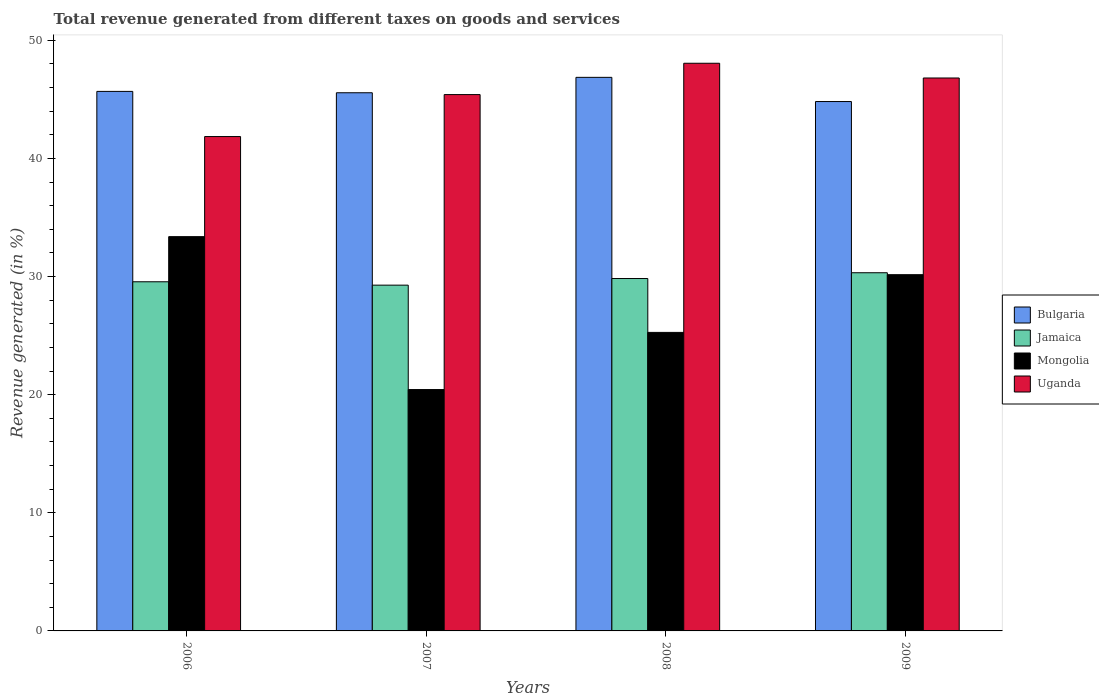How many different coloured bars are there?
Ensure brevity in your answer.  4. How many groups of bars are there?
Ensure brevity in your answer.  4. How many bars are there on the 2nd tick from the left?
Give a very brief answer. 4. What is the total revenue generated in Bulgaria in 2008?
Your response must be concise. 46.86. Across all years, what is the maximum total revenue generated in Mongolia?
Ensure brevity in your answer.  33.38. Across all years, what is the minimum total revenue generated in Bulgaria?
Ensure brevity in your answer.  44.81. In which year was the total revenue generated in Bulgaria maximum?
Your answer should be very brief. 2008. In which year was the total revenue generated in Mongolia minimum?
Your response must be concise. 2007. What is the total total revenue generated in Jamaica in the graph?
Keep it short and to the point. 118.98. What is the difference between the total revenue generated in Jamaica in 2007 and that in 2008?
Make the answer very short. -0.56. What is the difference between the total revenue generated in Bulgaria in 2009 and the total revenue generated in Mongolia in 2006?
Keep it short and to the point. 11.44. What is the average total revenue generated in Uganda per year?
Provide a short and direct response. 45.53. In the year 2009, what is the difference between the total revenue generated in Uganda and total revenue generated in Jamaica?
Keep it short and to the point. 16.49. In how many years, is the total revenue generated in Uganda greater than 18 %?
Ensure brevity in your answer.  4. What is the ratio of the total revenue generated in Uganda in 2008 to that in 2009?
Give a very brief answer. 1.03. Is the difference between the total revenue generated in Uganda in 2007 and 2009 greater than the difference between the total revenue generated in Jamaica in 2007 and 2009?
Offer a very short reply. No. What is the difference between the highest and the second highest total revenue generated in Bulgaria?
Make the answer very short. 1.19. What is the difference between the highest and the lowest total revenue generated in Bulgaria?
Your answer should be compact. 2.05. In how many years, is the total revenue generated in Bulgaria greater than the average total revenue generated in Bulgaria taken over all years?
Keep it short and to the point. 1. Is the sum of the total revenue generated in Mongolia in 2006 and 2007 greater than the maximum total revenue generated in Bulgaria across all years?
Give a very brief answer. Yes. What does the 3rd bar from the right in 2008 represents?
Provide a short and direct response. Jamaica. How many bars are there?
Keep it short and to the point. 16. How many years are there in the graph?
Your response must be concise. 4. What is the difference between two consecutive major ticks on the Y-axis?
Your answer should be very brief. 10. Are the values on the major ticks of Y-axis written in scientific E-notation?
Ensure brevity in your answer.  No. Does the graph contain any zero values?
Provide a succinct answer. No. What is the title of the graph?
Give a very brief answer. Total revenue generated from different taxes on goods and services. What is the label or title of the Y-axis?
Offer a terse response. Revenue generated (in %). What is the Revenue generated (in %) in Bulgaria in 2006?
Your answer should be very brief. 45.67. What is the Revenue generated (in %) of Jamaica in 2006?
Make the answer very short. 29.56. What is the Revenue generated (in %) in Mongolia in 2006?
Provide a succinct answer. 33.38. What is the Revenue generated (in %) of Uganda in 2006?
Provide a short and direct response. 41.85. What is the Revenue generated (in %) in Bulgaria in 2007?
Keep it short and to the point. 45.56. What is the Revenue generated (in %) in Jamaica in 2007?
Your answer should be very brief. 29.27. What is the Revenue generated (in %) of Mongolia in 2007?
Your response must be concise. 20.43. What is the Revenue generated (in %) of Uganda in 2007?
Provide a short and direct response. 45.4. What is the Revenue generated (in %) of Bulgaria in 2008?
Offer a terse response. 46.86. What is the Revenue generated (in %) of Jamaica in 2008?
Your response must be concise. 29.83. What is the Revenue generated (in %) in Mongolia in 2008?
Ensure brevity in your answer.  25.27. What is the Revenue generated (in %) of Uganda in 2008?
Offer a terse response. 48.06. What is the Revenue generated (in %) of Bulgaria in 2009?
Make the answer very short. 44.81. What is the Revenue generated (in %) in Jamaica in 2009?
Provide a short and direct response. 30.32. What is the Revenue generated (in %) of Mongolia in 2009?
Keep it short and to the point. 30.16. What is the Revenue generated (in %) in Uganda in 2009?
Your response must be concise. 46.81. Across all years, what is the maximum Revenue generated (in %) in Bulgaria?
Make the answer very short. 46.86. Across all years, what is the maximum Revenue generated (in %) in Jamaica?
Keep it short and to the point. 30.32. Across all years, what is the maximum Revenue generated (in %) in Mongolia?
Provide a short and direct response. 33.38. Across all years, what is the maximum Revenue generated (in %) in Uganda?
Your response must be concise. 48.06. Across all years, what is the minimum Revenue generated (in %) of Bulgaria?
Keep it short and to the point. 44.81. Across all years, what is the minimum Revenue generated (in %) in Jamaica?
Your response must be concise. 29.27. Across all years, what is the minimum Revenue generated (in %) of Mongolia?
Your answer should be compact. 20.43. Across all years, what is the minimum Revenue generated (in %) of Uganda?
Offer a terse response. 41.85. What is the total Revenue generated (in %) in Bulgaria in the graph?
Offer a terse response. 182.91. What is the total Revenue generated (in %) in Jamaica in the graph?
Make the answer very short. 118.98. What is the total Revenue generated (in %) in Mongolia in the graph?
Ensure brevity in your answer.  109.24. What is the total Revenue generated (in %) in Uganda in the graph?
Provide a short and direct response. 182.12. What is the difference between the Revenue generated (in %) in Bulgaria in 2006 and that in 2007?
Give a very brief answer. 0.11. What is the difference between the Revenue generated (in %) in Jamaica in 2006 and that in 2007?
Your answer should be compact. 0.28. What is the difference between the Revenue generated (in %) of Mongolia in 2006 and that in 2007?
Provide a succinct answer. 12.94. What is the difference between the Revenue generated (in %) of Uganda in 2006 and that in 2007?
Your response must be concise. -3.55. What is the difference between the Revenue generated (in %) in Bulgaria in 2006 and that in 2008?
Your answer should be compact. -1.19. What is the difference between the Revenue generated (in %) of Jamaica in 2006 and that in 2008?
Give a very brief answer. -0.28. What is the difference between the Revenue generated (in %) in Mongolia in 2006 and that in 2008?
Your answer should be very brief. 8.11. What is the difference between the Revenue generated (in %) in Uganda in 2006 and that in 2008?
Your response must be concise. -6.2. What is the difference between the Revenue generated (in %) of Bulgaria in 2006 and that in 2009?
Make the answer very short. 0.86. What is the difference between the Revenue generated (in %) of Jamaica in 2006 and that in 2009?
Keep it short and to the point. -0.77. What is the difference between the Revenue generated (in %) in Mongolia in 2006 and that in 2009?
Provide a succinct answer. 3.22. What is the difference between the Revenue generated (in %) in Uganda in 2006 and that in 2009?
Offer a terse response. -4.96. What is the difference between the Revenue generated (in %) of Bulgaria in 2007 and that in 2008?
Provide a succinct answer. -1.3. What is the difference between the Revenue generated (in %) in Jamaica in 2007 and that in 2008?
Provide a succinct answer. -0.56. What is the difference between the Revenue generated (in %) of Mongolia in 2007 and that in 2008?
Your answer should be very brief. -4.84. What is the difference between the Revenue generated (in %) in Uganda in 2007 and that in 2008?
Keep it short and to the point. -2.65. What is the difference between the Revenue generated (in %) of Bulgaria in 2007 and that in 2009?
Provide a short and direct response. 0.74. What is the difference between the Revenue generated (in %) of Jamaica in 2007 and that in 2009?
Provide a short and direct response. -1.05. What is the difference between the Revenue generated (in %) of Mongolia in 2007 and that in 2009?
Provide a short and direct response. -9.73. What is the difference between the Revenue generated (in %) of Uganda in 2007 and that in 2009?
Provide a short and direct response. -1.4. What is the difference between the Revenue generated (in %) of Bulgaria in 2008 and that in 2009?
Make the answer very short. 2.05. What is the difference between the Revenue generated (in %) in Jamaica in 2008 and that in 2009?
Provide a short and direct response. -0.49. What is the difference between the Revenue generated (in %) of Mongolia in 2008 and that in 2009?
Ensure brevity in your answer.  -4.89. What is the difference between the Revenue generated (in %) of Uganda in 2008 and that in 2009?
Provide a succinct answer. 1.25. What is the difference between the Revenue generated (in %) of Bulgaria in 2006 and the Revenue generated (in %) of Jamaica in 2007?
Offer a terse response. 16.4. What is the difference between the Revenue generated (in %) of Bulgaria in 2006 and the Revenue generated (in %) of Mongolia in 2007?
Give a very brief answer. 25.24. What is the difference between the Revenue generated (in %) in Bulgaria in 2006 and the Revenue generated (in %) in Uganda in 2007?
Your answer should be compact. 0.27. What is the difference between the Revenue generated (in %) in Jamaica in 2006 and the Revenue generated (in %) in Mongolia in 2007?
Your answer should be very brief. 9.12. What is the difference between the Revenue generated (in %) of Jamaica in 2006 and the Revenue generated (in %) of Uganda in 2007?
Your answer should be very brief. -15.85. What is the difference between the Revenue generated (in %) of Mongolia in 2006 and the Revenue generated (in %) of Uganda in 2007?
Ensure brevity in your answer.  -12.03. What is the difference between the Revenue generated (in %) in Bulgaria in 2006 and the Revenue generated (in %) in Jamaica in 2008?
Offer a very short reply. 15.84. What is the difference between the Revenue generated (in %) in Bulgaria in 2006 and the Revenue generated (in %) in Mongolia in 2008?
Give a very brief answer. 20.4. What is the difference between the Revenue generated (in %) in Bulgaria in 2006 and the Revenue generated (in %) in Uganda in 2008?
Give a very brief answer. -2.38. What is the difference between the Revenue generated (in %) in Jamaica in 2006 and the Revenue generated (in %) in Mongolia in 2008?
Offer a very short reply. 4.29. What is the difference between the Revenue generated (in %) of Jamaica in 2006 and the Revenue generated (in %) of Uganda in 2008?
Provide a succinct answer. -18.5. What is the difference between the Revenue generated (in %) of Mongolia in 2006 and the Revenue generated (in %) of Uganda in 2008?
Ensure brevity in your answer.  -14.68. What is the difference between the Revenue generated (in %) of Bulgaria in 2006 and the Revenue generated (in %) of Jamaica in 2009?
Your answer should be very brief. 15.35. What is the difference between the Revenue generated (in %) of Bulgaria in 2006 and the Revenue generated (in %) of Mongolia in 2009?
Ensure brevity in your answer.  15.52. What is the difference between the Revenue generated (in %) in Bulgaria in 2006 and the Revenue generated (in %) in Uganda in 2009?
Your answer should be very brief. -1.14. What is the difference between the Revenue generated (in %) in Jamaica in 2006 and the Revenue generated (in %) in Mongolia in 2009?
Keep it short and to the point. -0.6. What is the difference between the Revenue generated (in %) in Jamaica in 2006 and the Revenue generated (in %) in Uganda in 2009?
Your response must be concise. -17.25. What is the difference between the Revenue generated (in %) of Mongolia in 2006 and the Revenue generated (in %) of Uganda in 2009?
Offer a terse response. -13.43. What is the difference between the Revenue generated (in %) of Bulgaria in 2007 and the Revenue generated (in %) of Jamaica in 2008?
Offer a very short reply. 15.73. What is the difference between the Revenue generated (in %) of Bulgaria in 2007 and the Revenue generated (in %) of Mongolia in 2008?
Provide a short and direct response. 20.29. What is the difference between the Revenue generated (in %) of Bulgaria in 2007 and the Revenue generated (in %) of Uganda in 2008?
Provide a short and direct response. -2.5. What is the difference between the Revenue generated (in %) in Jamaica in 2007 and the Revenue generated (in %) in Mongolia in 2008?
Offer a very short reply. 4. What is the difference between the Revenue generated (in %) in Jamaica in 2007 and the Revenue generated (in %) in Uganda in 2008?
Your answer should be compact. -18.78. What is the difference between the Revenue generated (in %) of Mongolia in 2007 and the Revenue generated (in %) of Uganda in 2008?
Your response must be concise. -27.62. What is the difference between the Revenue generated (in %) of Bulgaria in 2007 and the Revenue generated (in %) of Jamaica in 2009?
Ensure brevity in your answer.  15.24. What is the difference between the Revenue generated (in %) in Bulgaria in 2007 and the Revenue generated (in %) in Mongolia in 2009?
Keep it short and to the point. 15.4. What is the difference between the Revenue generated (in %) of Bulgaria in 2007 and the Revenue generated (in %) of Uganda in 2009?
Your answer should be very brief. -1.25. What is the difference between the Revenue generated (in %) of Jamaica in 2007 and the Revenue generated (in %) of Mongolia in 2009?
Give a very brief answer. -0.89. What is the difference between the Revenue generated (in %) in Jamaica in 2007 and the Revenue generated (in %) in Uganda in 2009?
Keep it short and to the point. -17.54. What is the difference between the Revenue generated (in %) in Mongolia in 2007 and the Revenue generated (in %) in Uganda in 2009?
Your answer should be very brief. -26.38. What is the difference between the Revenue generated (in %) of Bulgaria in 2008 and the Revenue generated (in %) of Jamaica in 2009?
Offer a terse response. 16.54. What is the difference between the Revenue generated (in %) in Bulgaria in 2008 and the Revenue generated (in %) in Mongolia in 2009?
Offer a very short reply. 16.7. What is the difference between the Revenue generated (in %) in Bulgaria in 2008 and the Revenue generated (in %) in Uganda in 2009?
Keep it short and to the point. 0.05. What is the difference between the Revenue generated (in %) of Jamaica in 2008 and the Revenue generated (in %) of Mongolia in 2009?
Your answer should be very brief. -0.32. What is the difference between the Revenue generated (in %) in Jamaica in 2008 and the Revenue generated (in %) in Uganda in 2009?
Your response must be concise. -16.98. What is the difference between the Revenue generated (in %) in Mongolia in 2008 and the Revenue generated (in %) in Uganda in 2009?
Offer a terse response. -21.54. What is the average Revenue generated (in %) in Bulgaria per year?
Give a very brief answer. 45.73. What is the average Revenue generated (in %) of Jamaica per year?
Ensure brevity in your answer.  29.75. What is the average Revenue generated (in %) in Mongolia per year?
Ensure brevity in your answer.  27.31. What is the average Revenue generated (in %) in Uganda per year?
Your response must be concise. 45.53. In the year 2006, what is the difference between the Revenue generated (in %) in Bulgaria and Revenue generated (in %) in Jamaica?
Offer a terse response. 16.12. In the year 2006, what is the difference between the Revenue generated (in %) of Bulgaria and Revenue generated (in %) of Mongolia?
Provide a short and direct response. 12.3. In the year 2006, what is the difference between the Revenue generated (in %) in Bulgaria and Revenue generated (in %) in Uganda?
Your answer should be compact. 3.82. In the year 2006, what is the difference between the Revenue generated (in %) of Jamaica and Revenue generated (in %) of Mongolia?
Keep it short and to the point. -3.82. In the year 2006, what is the difference between the Revenue generated (in %) in Jamaica and Revenue generated (in %) in Uganda?
Your answer should be compact. -12.29. In the year 2006, what is the difference between the Revenue generated (in %) of Mongolia and Revenue generated (in %) of Uganda?
Your answer should be very brief. -8.47. In the year 2007, what is the difference between the Revenue generated (in %) in Bulgaria and Revenue generated (in %) in Jamaica?
Keep it short and to the point. 16.29. In the year 2007, what is the difference between the Revenue generated (in %) in Bulgaria and Revenue generated (in %) in Mongolia?
Make the answer very short. 25.13. In the year 2007, what is the difference between the Revenue generated (in %) in Bulgaria and Revenue generated (in %) in Uganda?
Your answer should be compact. 0.15. In the year 2007, what is the difference between the Revenue generated (in %) in Jamaica and Revenue generated (in %) in Mongolia?
Give a very brief answer. 8.84. In the year 2007, what is the difference between the Revenue generated (in %) of Jamaica and Revenue generated (in %) of Uganda?
Ensure brevity in your answer.  -16.13. In the year 2007, what is the difference between the Revenue generated (in %) of Mongolia and Revenue generated (in %) of Uganda?
Your answer should be very brief. -24.97. In the year 2008, what is the difference between the Revenue generated (in %) of Bulgaria and Revenue generated (in %) of Jamaica?
Provide a succinct answer. 17.03. In the year 2008, what is the difference between the Revenue generated (in %) of Bulgaria and Revenue generated (in %) of Mongolia?
Provide a succinct answer. 21.59. In the year 2008, what is the difference between the Revenue generated (in %) of Bulgaria and Revenue generated (in %) of Uganda?
Keep it short and to the point. -1.19. In the year 2008, what is the difference between the Revenue generated (in %) in Jamaica and Revenue generated (in %) in Mongolia?
Provide a succinct answer. 4.56. In the year 2008, what is the difference between the Revenue generated (in %) of Jamaica and Revenue generated (in %) of Uganda?
Give a very brief answer. -18.22. In the year 2008, what is the difference between the Revenue generated (in %) in Mongolia and Revenue generated (in %) in Uganda?
Ensure brevity in your answer.  -22.78. In the year 2009, what is the difference between the Revenue generated (in %) of Bulgaria and Revenue generated (in %) of Jamaica?
Give a very brief answer. 14.49. In the year 2009, what is the difference between the Revenue generated (in %) of Bulgaria and Revenue generated (in %) of Mongolia?
Provide a short and direct response. 14.66. In the year 2009, what is the difference between the Revenue generated (in %) in Bulgaria and Revenue generated (in %) in Uganda?
Offer a terse response. -1.99. In the year 2009, what is the difference between the Revenue generated (in %) of Jamaica and Revenue generated (in %) of Mongolia?
Your answer should be very brief. 0.16. In the year 2009, what is the difference between the Revenue generated (in %) of Jamaica and Revenue generated (in %) of Uganda?
Keep it short and to the point. -16.49. In the year 2009, what is the difference between the Revenue generated (in %) of Mongolia and Revenue generated (in %) of Uganda?
Ensure brevity in your answer.  -16.65. What is the ratio of the Revenue generated (in %) in Bulgaria in 2006 to that in 2007?
Keep it short and to the point. 1. What is the ratio of the Revenue generated (in %) in Jamaica in 2006 to that in 2007?
Make the answer very short. 1.01. What is the ratio of the Revenue generated (in %) in Mongolia in 2006 to that in 2007?
Offer a terse response. 1.63. What is the ratio of the Revenue generated (in %) of Uganda in 2006 to that in 2007?
Make the answer very short. 0.92. What is the ratio of the Revenue generated (in %) in Bulgaria in 2006 to that in 2008?
Your response must be concise. 0.97. What is the ratio of the Revenue generated (in %) in Jamaica in 2006 to that in 2008?
Make the answer very short. 0.99. What is the ratio of the Revenue generated (in %) in Mongolia in 2006 to that in 2008?
Make the answer very short. 1.32. What is the ratio of the Revenue generated (in %) in Uganda in 2006 to that in 2008?
Your answer should be very brief. 0.87. What is the ratio of the Revenue generated (in %) of Bulgaria in 2006 to that in 2009?
Offer a very short reply. 1.02. What is the ratio of the Revenue generated (in %) in Jamaica in 2006 to that in 2009?
Provide a succinct answer. 0.97. What is the ratio of the Revenue generated (in %) of Mongolia in 2006 to that in 2009?
Your answer should be compact. 1.11. What is the ratio of the Revenue generated (in %) in Uganda in 2006 to that in 2009?
Your answer should be very brief. 0.89. What is the ratio of the Revenue generated (in %) of Bulgaria in 2007 to that in 2008?
Your answer should be very brief. 0.97. What is the ratio of the Revenue generated (in %) in Jamaica in 2007 to that in 2008?
Your answer should be compact. 0.98. What is the ratio of the Revenue generated (in %) of Mongolia in 2007 to that in 2008?
Provide a short and direct response. 0.81. What is the ratio of the Revenue generated (in %) in Uganda in 2007 to that in 2008?
Provide a short and direct response. 0.94. What is the ratio of the Revenue generated (in %) of Bulgaria in 2007 to that in 2009?
Your response must be concise. 1.02. What is the ratio of the Revenue generated (in %) in Jamaica in 2007 to that in 2009?
Your answer should be very brief. 0.97. What is the ratio of the Revenue generated (in %) in Mongolia in 2007 to that in 2009?
Your answer should be very brief. 0.68. What is the ratio of the Revenue generated (in %) of Uganda in 2007 to that in 2009?
Your answer should be very brief. 0.97. What is the ratio of the Revenue generated (in %) in Bulgaria in 2008 to that in 2009?
Ensure brevity in your answer.  1.05. What is the ratio of the Revenue generated (in %) of Jamaica in 2008 to that in 2009?
Provide a short and direct response. 0.98. What is the ratio of the Revenue generated (in %) in Mongolia in 2008 to that in 2009?
Give a very brief answer. 0.84. What is the ratio of the Revenue generated (in %) in Uganda in 2008 to that in 2009?
Offer a terse response. 1.03. What is the difference between the highest and the second highest Revenue generated (in %) of Bulgaria?
Provide a short and direct response. 1.19. What is the difference between the highest and the second highest Revenue generated (in %) in Jamaica?
Offer a very short reply. 0.49. What is the difference between the highest and the second highest Revenue generated (in %) of Mongolia?
Give a very brief answer. 3.22. What is the difference between the highest and the second highest Revenue generated (in %) in Uganda?
Provide a short and direct response. 1.25. What is the difference between the highest and the lowest Revenue generated (in %) of Bulgaria?
Provide a succinct answer. 2.05. What is the difference between the highest and the lowest Revenue generated (in %) of Jamaica?
Make the answer very short. 1.05. What is the difference between the highest and the lowest Revenue generated (in %) in Mongolia?
Your response must be concise. 12.94. What is the difference between the highest and the lowest Revenue generated (in %) in Uganda?
Provide a short and direct response. 6.2. 